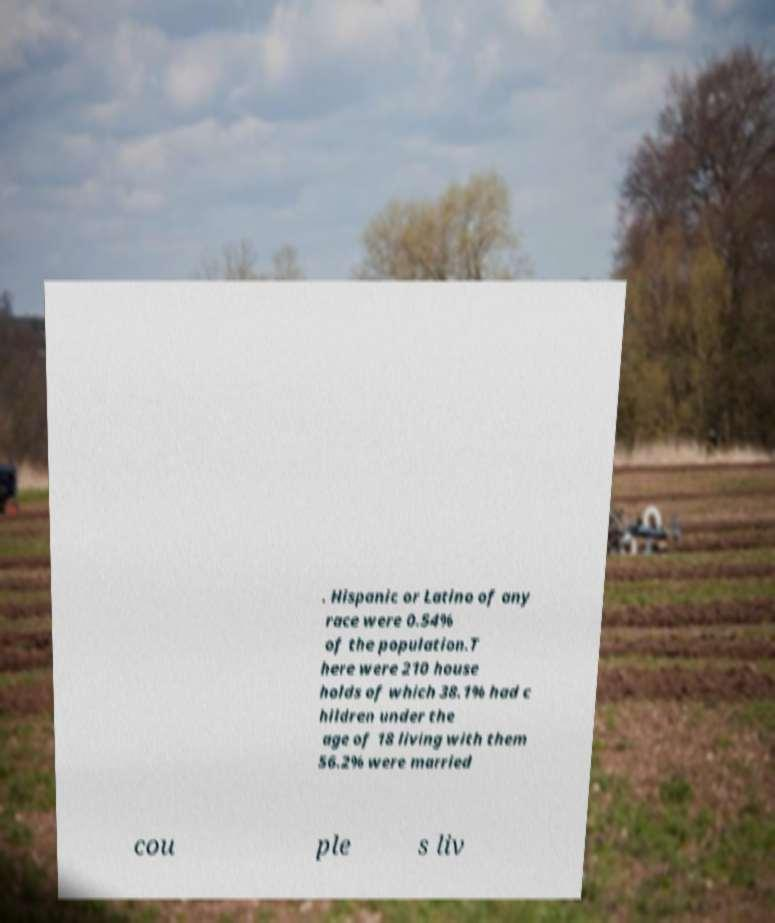Could you extract and type out the text from this image? . Hispanic or Latino of any race were 0.54% of the population.T here were 210 house holds of which 38.1% had c hildren under the age of 18 living with them 56.2% were married cou ple s liv 